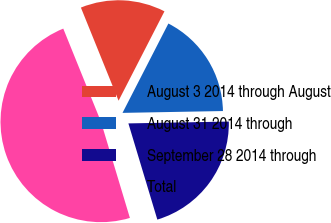<chart> <loc_0><loc_0><loc_500><loc_500><pie_chart><fcel>August 3 2014 through August<fcel>August 31 2014 through<fcel>September 28 2014 through<fcel>Total<nl><fcel>13.67%<fcel>17.16%<fcel>20.64%<fcel>48.53%<nl></chart> 